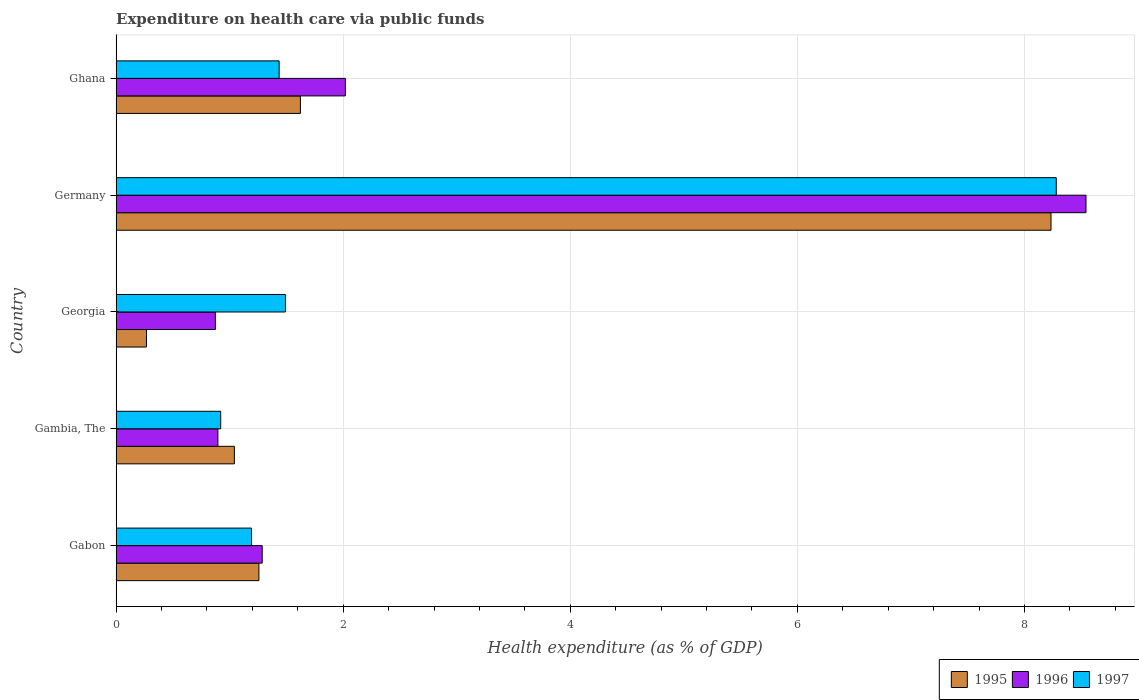How many different coloured bars are there?
Ensure brevity in your answer.  3. How many bars are there on the 3rd tick from the top?
Your answer should be very brief. 3. In how many cases, is the number of bars for a given country not equal to the number of legend labels?
Provide a succinct answer. 0. What is the expenditure made on health care in 1995 in Gambia, The?
Offer a very short reply. 1.04. Across all countries, what is the maximum expenditure made on health care in 1997?
Make the answer very short. 8.28. Across all countries, what is the minimum expenditure made on health care in 1997?
Offer a very short reply. 0.92. In which country was the expenditure made on health care in 1997 minimum?
Give a very brief answer. Gambia, The. What is the total expenditure made on health care in 1996 in the graph?
Provide a short and direct response. 13.62. What is the difference between the expenditure made on health care in 1997 in Germany and that in Ghana?
Provide a short and direct response. 6.84. What is the difference between the expenditure made on health care in 1996 in Ghana and the expenditure made on health care in 1997 in Gabon?
Your answer should be compact. 0.83. What is the average expenditure made on health care in 1995 per country?
Keep it short and to the point. 2.48. What is the difference between the expenditure made on health care in 1995 and expenditure made on health care in 1997 in Germany?
Give a very brief answer. -0.05. What is the ratio of the expenditure made on health care in 1995 in Gambia, The to that in Georgia?
Make the answer very short. 3.9. Is the expenditure made on health care in 1995 in Germany less than that in Ghana?
Provide a short and direct response. No. Is the difference between the expenditure made on health care in 1995 in Gabon and Germany greater than the difference between the expenditure made on health care in 1997 in Gabon and Germany?
Your response must be concise. Yes. What is the difference between the highest and the second highest expenditure made on health care in 1995?
Provide a short and direct response. 6.61. What is the difference between the highest and the lowest expenditure made on health care in 1996?
Keep it short and to the point. 7.67. Is the sum of the expenditure made on health care in 1996 in Gambia, The and Georgia greater than the maximum expenditure made on health care in 1995 across all countries?
Your answer should be very brief. No. What does the 2nd bar from the top in Georgia represents?
Offer a terse response. 1996. Is it the case that in every country, the sum of the expenditure made on health care in 1996 and expenditure made on health care in 1997 is greater than the expenditure made on health care in 1995?
Make the answer very short. Yes. How many bars are there?
Your answer should be compact. 15. Are all the bars in the graph horizontal?
Your response must be concise. Yes. Where does the legend appear in the graph?
Your answer should be very brief. Bottom right. How are the legend labels stacked?
Offer a terse response. Horizontal. What is the title of the graph?
Offer a terse response. Expenditure on health care via public funds. What is the label or title of the X-axis?
Ensure brevity in your answer.  Health expenditure (as % of GDP). What is the label or title of the Y-axis?
Keep it short and to the point. Country. What is the Health expenditure (as % of GDP) in 1995 in Gabon?
Provide a short and direct response. 1.26. What is the Health expenditure (as % of GDP) in 1996 in Gabon?
Offer a terse response. 1.29. What is the Health expenditure (as % of GDP) in 1997 in Gabon?
Your response must be concise. 1.19. What is the Health expenditure (as % of GDP) of 1995 in Gambia, The?
Make the answer very short. 1.04. What is the Health expenditure (as % of GDP) of 1996 in Gambia, The?
Your answer should be very brief. 0.9. What is the Health expenditure (as % of GDP) of 1997 in Gambia, The?
Your answer should be very brief. 0.92. What is the Health expenditure (as % of GDP) in 1995 in Georgia?
Your response must be concise. 0.27. What is the Health expenditure (as % of GDP) of 1996 in Georgia?
Provide a succinct answer. 0.87. What is the Health expenditure (as % of GDP) in 1997 in Georgia?
Offer a terse response. 1.49. What is the Health expenditure (as % of GDP) in 1995 in Germany?
Your response must be concise. 8.23. What is the Health expenditure (as % of GDP) of 1996 in Germany?
Make the answer very short. 8.54. What is the Health expenditure (as % of GDP) of 1997 in Germany?
Your answer should be compact. 8.28. What is the Health expenditure (as % of GDP) in 1995 in Ghana?
Offer a terse response. 1.62. What is the Health expenditure (as % of GDP) of 1996 in Ghana?
Provide a succinct answer. 2.02. What is the Health expenditure (as % of GDP) in 1997 in Ghana?
Provide a short and direct response. 1.44. Across all countries, what is the maximum Health expenditure (as % of GDP) in 1995?
Keep it short and to the point. 8.23. Across all countries, what is the maximum Health expenditure (as % of GDP) in 1996?
Offer a very short reply. 8.54. Across all countries, what is the maximum Health expenditure (as % of GDP) in 1997?
Provide a short and direct response. 8.28. Across all countries, what is the minimum Health expenditure (as % of GDP) in 1995?
Your answer should be compact. 0.27. Across all countries, what is the minimum Health expenditure (as % of GDP) of 1996?
Your response must be concise. 0.87. Across all countries, what is the minimum Health expenditure (as % of GDP) in 1997?
Offer a terse response. 0.92. What is the total Health expenditure (as % of GDP) of 1995 in the graph?
Ensure brevity in your answer.  12.42. What is the total Health expenditure (as % of GDP) in 1996 in the graph?
Provide a short and direct response. 13.62. What is the total Health expenditure (as % of GDP) in 1997 in the graph?
Offer a very short reply. 13.32. What is the difference between the Health expenditure (as % of GDP) in 1995 in Gabon and that in Gambia, The?
Offer a very short reply. 0.22. What is the difference between the Health expenditure (as % of GDP) of 1996 in Gabon and that in Gambia, The?
Make the answer very short. 0.39. What is the difference between the Health expenditure (as % of GDP) of 1997 in Gabon and that in Gambia, The?
Provide a short and direct response. 0.27. What is the difference between the Health expenditure (as % of GDP) of 1995 in Gabon and that in Georgia?
Offer a terse response. 0.99. What is the difference between the Health expenditure (as % of GDP) in 1996 in Gabon and that in Georgia?
Make the answer very short. 0.41. What is the difference between the Health expenditure (as % of GDP) of 1997 in Gabon and that in Georgia?
Your answer should be compact. -0.3. What is the difference between the Health expenditure (as % of GDP) in 1995 in Gabon and that in Germany?
Your answer should be very brief. -6.98. What is the difference between the Health expenditure (as % of GDP) in 1996 in Gabon and that in Germany?
Provide a succinct answer. -7.26. What is the difference between the Health expenditure (as % of GDP) of 1997 in Gabon and that in Germany?
Your answer should be compact. -7.09. What is the difference between the Health expenditure (as % of GDP) of 1995 in Gabon and that in Ghana?
Offer a terse response. -0.37. What is the difference between the Health expenditure (as % of GDP) in 1996 in Gabon and that in Ghana?
Give a very brief answer. -0.73. What is the difference between the Health expenditure (as % of GDP) in 1997 in Gabon and that in Ghana?
Your answer should be compact. -0.24. What is the difference between the Health expenditure (as % of GDP) of 1995 in Gambia, The and that in Georgia?
Your response must be concise. 0.77. What is the difference between the Health expenditure (as % of GDP) in 1996 in Gambia, The and that in Georgia?
Make the answer very short. 0.02. What is the difference between the Health expenditure (as % of GDP) of 1997 in Gambia, The and that in Georgia?
Offer a terse response. -0.57. What is the difference between the Health expenditure (as % of GDP) in 1995 in Gambia, The and that in Germany?
Provide a short and direct response. -7.19. What is the difference between the Health expenditure (as % of GDP) in 1996 in Gambia, The and that in Germany?
Your answer should be very brief. -7.65. What is the difference between the Health expenditure (as % of GDP) in 1997 in Gambia, The and that in Germany?
Your answer should be very brief. -7.36. What is the difference between the Health expenditure (as % of GDP) in 1995 in Gambia, The and that in Ghana?
Your answer should be compact. -0.58. What is the difference between the Health expenditure (as % of GDP) of 1996 in Gambia, The and that in Ghana?
Give a very brief answer. -1.12. What is the difference between the Health expenditure (as % of GDP) in 1997 in Gambia, The and that in Ghana?
Your answer should be compact. -0.51. What is the difference between the Health expenditure (as % of GDP) of 1995 in Georgia and that in Germany?
Offer a terse response. -7.97. What is the difference between the Health expenditure (as % of GDP) of 1996 in Georgia and that in Germany?
Ensure brevity in your answer.  -7.67. What is the difference between the Health expenditure (as % of GDP) of 1997 in Georgia and that in Germany?
Offer a terse response. -6.79. What is the difference between the Health expenditure (as % of GDP) of 1995 in Georgia and that in Ghana?
Offer a terse response. -1.36. What is the difference between the Health expenditure (as % of GDP) in 1996 in Georgia and that in Ghana?
Provide a short and direct response. -1.14. What is the difference between the Health expenditure (as % of GDP) of 1997 in Georgia and that in Ghana?
Offer a terse response. 0.06. What is the difference between the Health expenditure (as % of GDP) of 1995 in Germany and that in Ghana?
Ensure brevity in your answer.  6.61. What is the difference between the Health expenditure (as % of GDP) of 1996 in Germany and that in Ghana?
Make the answer very short. 6.52. What is the difference between the Health expenditure (as % of GDP) of 1997 in Germany and that in Ghana?
Your answer should be compact. 6.84. What is the difference between the Health expenditure (as % of GDP) in 1995 in Gabon and the Health expenditure (as % of GDP) in 1996 in Gambia, The?
Your answer should be compact. 0.36. What is the difference between the Health expenditure (as % of GDP) of 1995 in Gabon and the Health expenditure (as % of GDP) of 1997 in Gambia, The?
Give a very brief answer. 0.34. What is the difference between the Health expenditure (as % of GDP) in 1996 in Gabon and the Health expenditure (as % of GDP) in 1997 in Gambia, The?
Make the answer very short. 0.37. What is the difference between the Health expenditure (as % of GDP) in 1995 in Gabon and the Health expenditure (as % of GDP) in 1996 in Georgia?
Provide a short and direct response. 0.38. What is the difference between the Health expenditure (as % of GDP) of 1995 in Gabon and the Health expenditure (as % of GDP) of 1997 in Georgia?
Offer a very short reply. -0.23. What is the difference between the Health expenditure (as % of GDP) in 1996 in Gabon and the Health expenditure (as % of GDP) in 1997 in Georgia?
Keep it short and to the point. -0.2. What is the difference between the Health expenditure (as % of GDP) in 1995 in Gabon and the Health expenditure (as % of GDP) in 1996 in Germany?
Your answer should be compact. -7.28. What is the difference between the Health expenditure (as % of GDP) of 1995 in Gabon and the Health expenditure (as % of GDP) of 1997 in Germany?
Your response must be concise. -7.02. What is the difference between the Health expenditure (as % of GDP) of 1996 in Gabon and the Health expenditure (as % of GDP) of 1997 in Germany?
Offer a terse response. -6.99. What is the difference between the Health expenditure (as % of GDP) in 1995 in Gabon and the Health expenditure (as % of GDP) in 1996 in Ghana?
Your answer should be compact. -0.76. What is the difference between the Health expenditure (as % of GDP) in 1995 in Gabon and the Health expenditure (as % of GDP) in 1997 in Ghana?
Your response must be concise. -0.18. What is the difference between the Health expenditure (as % of GDP) in 1996 in Gabon and the Health expenditure (as % of GDP) in 1997 in Ghana?
Your response must be concise. -0.15. What is the difference between the Health expenditure (as % of GDP) of 1995 in Gambia, The and the Health expenditure (as % of GDP) of 1996 in Georgia?
Your answer should be compact. 0.17. What is the difference between the Health expenditure (as % of GDP) of 1995 in Gambia, The and the Health expenditure (as % of GDP) of 1997 in Georgia?
Keep it short and to the point. -0.45. What is the difference between the Health expenditure (as % of GDP) in 1996 in Gambia, The and the Health expenditure (as % of GDP) in 1997 in Georgia?
Your answer should be compact. -0.6. What is the difference between the Health expenditure (as % of GDP) in 1995 in Gambia, The and the Health expenditure (as % of GDP) in 1996 in Germany?
Your answer should be very brief. -7.5. What is the difference between the Health expenditure (as % of GDP) in 1995 in Gambia, The and the Health expenditure (as % of GDP) in 1997 in Germany?
Your response must be concise. -7.24. What is the difference between the Health expenditure (as % of GDP) of 1996 in Gambia, The and the Health expenditure (as % of GDP) of 1997 in Germany?
Your answer should be very brief. -7.38. What is the difference between the Health expenditure (as % of GDP) in 1995 in Gambia, The and the Health expenditure (as % of GDP) in 1996 in Ghana?
Your answer should be compact. -0.98. What is the difference between the Health expenditure (as % of GDP) in 1995 in Gambia, The and the Health expenditure (as % of GDP) in 1997 in Ghana?
Your answer should be very brief. -0.39. What is the difference between the Health expenditure (as % of GDP) of 1996 in Gambia, The and the Health expenditure (as % of GDP) of 1997 in Ghana?
Your response must be concise. -0.54. What is the difference between the Health expenditure (as % of GDP) of 1995 in Georgia and the Health expenditure (as % of GDP) of 1996 in Germany?
Provide a short and direct response. -8.27. What is the difference between the Health expenditure (as % of GDP) of 1995 in Georgia and the Health expenditure (as % of GDP) of 1997 in Germany?
Offer a terse response. -8.01. What is the difference between the Health expenditure (as % of GDP) in 1996 in Georgia and the Health expenditure (as % of GDP) in 1997 in Germany?
Ensure brevity in your answer.  -7.41. What is the difference between the Health expenditure (as % of GDP) in 1995 in Georgia and the Health expenditure (as % of GDP) in 1996 in Ghana?
Your response must be concise. -1.75. What is the difference between the Health expenditure (as % of GDP) in 1995 in Georgia and the Health expenditure (as % of GDP) in 1997 in Ghana?
Your answer should be compact. -1.17. What is the difference between the Health expenditure (as % of GDP) of 1996 in Georgia and the Health expenditure (as % of GDP) of 1997 in Ghana?
Your response must be concise. -0.56. What is the difference between the Health expenditure (as % of GDP) of 1995 in Germany and the Health expenditure (as % of GDP) of 1996 in Ghana?
Make the answer very short. 6.21. What is the difference between the Health expenditure (as % of GDP) of 1995 in Germany and the Health expenditure (as % of GDP) of 1997 in Ghana?
Keep it short and to the point. 6.8. What is the difference between the Health expenditure (as % of GDP) of 1996 in Germany and the Health expenditure (as % of GDP) of 1997 in Ghana?
Your response must be concise. 7.11. What is the average Health expenditure (as % of GDP) of 1995 per country?
Provide a short and direct response. 2.48. What is the average Health expenditure (as % of GDP) of 1996 per country?
Give a very brief answer. 2.72. What is the average Health expenditure (as % of GDP) of 1997 per country?
Keep it short and to the point. 2.66. What is the difference between the Health expenditure (as % of GDP) in 1995 and Health expenditure (as % of GDP) in 1996 in Gabon?
Your answer should be compact. -0.03. What is the difference between the Health expenditure (as % of GDP) in 1995 and Health expenditure (as % of GDP) in 1997 in Gabon?
Your response must be concise. 0.07. What is the difference between the Health expenditure (as % of GDP) in 1996 and Health expenditure (as % of GDP) in 1997 in Gabon?
Keep it short and to the point. 0.09. What is the difference between the Health expenditure (as % of GDP) in 1995 and Health expenditure (as % of GDP) in 1996 in Gambia, The?
Ensure brevity in your answer.  0.15. What is the difference between the Health expenditure (as % of GDP) in 1995 and Health expenditure (as % of GDP) in 1997 in Gambia, The?
Keep it short and to the point. 0.12. What is the difference between the Health expenditure (as % of GDP) of 1996 and Health expenditure (as % of GDP) of 1997 in Gambia, The?
Your answer should be compact. -0.02. What is the difference between the Health expenditure (as % of GDP) of 1995 and Health expenditure (as % of GDP) of 1996 in Georgia?
Give a very brief answer. -0.61. What is the difference between the Health expenditure (as % of GDP) of 1995 and Health expenditure (as % of GDP) of 1997 in Georgia?
Your answer should be very brief. -1.22. What is the difference between the Health expenditure (as % of GDP) in 1996 and Health expenditure (as % of GDP) in 1997 in Georgia?
Offer a very short reply. -0.62. What is the difference between the Health expenditure (as % of GDP) in 1995 and Health expenditure (as % of GDP) in 1996 in Germany?
Your answer should be very brief. -0.31. What is the difference between the Health expenditure (as % of GDP) of 1995 and Health expenditure (as % of GDP) of 1997 in Germany?
Provide a short and direct response. -0.05. What is the difference between the Health expenditure (as % of GDP) of 1996 and Health expenditure (as % of GDP) of 1997 in Germany?
Keep it short and to the point. 0.26. What is the difference between the Health expenditure (as % of GDP) of 1995 and Health expenditure (as % of GDP) of 1996 in Ghana?
Offer a terse response. -0.4. What is the difference between the Health expenditure (as % of GDP) of 1995 and Health expenditure (as % of GDP) of 1997 in Ghana?
Offer a terse response. 0.19. What is the difference between the Health expenditure (as % of GDP) of 1996 and Health expenditure (as % of GDP) of 1997 in Ghana?
Offer a very short reply. 0.58. What is the ratio of the Health expenditure (as % of GDP) of 1995 in Gabon to that in Gambia, The?
Your answer should be compact. 1.21. What is the ratio of the Health expenditure (as % of GDP) of 1996 in Gabon to that in Gambia, The?
Keep it short and to the point. 1.44. What is the ratio of the Health expenditure (as % of GDP) in 1997 in Gabon to that in Gambia, The?
Offer a very short reply. 1.29. What is the ratio of the Health expenditure (as % of GDP) of 1995 in Gabon to that in Georgia?
Provide a succinct answer. 4.7. What is the ratio of the Health expenditure (as % of GDP) in 1996 in Gabon to that in Georgia?
Ensure brevity in your answer.  1.47. What is the ratio of the Health expenditure (as % of GDP) of 1997 in Gabon to that in Georgia?
Provide a short and direct response. 0.8. What is the ratio of the Health expenditure (as % of GDP) of 1995 in Gabon to that in Germany?
Your answer should be very brief. 0.15. What is the ratio of the Health expenditure (as % of GDP) in 1996 in Gabon to that in Germany?
Provide a short and direct response. 0.15. What is the ratio of the Health expenditure (as % of GDP) of 1997 in Gabon to that in Germany?
Offer a very short reply. 0.14. What is the ratio of the Health expenditure (as % of GDP) in 1995 in Gabon to that in Ghana?
Your answer should be compact. 0.77. What is the ratio of the Health expenditure (as % of GDP) of 1996 in Gabon to that in Ghana?
Offer a very short reply. 0.64. What is the ratio of the Health expenditure (as % of GDP) of 1997 in Gabon to that in Ghana?
Your answer should be very brief. 0.83. What is the ratio of the Health expenditure (as % of GDP) of 1995 in Gambia, The to that in Georgia?
Keep it short and to the point. 3.9. What is the ratio of the Health expenditure (as % of GDP) in 1996 in Gambia, The to that in Georgia?
Your answer should be compact. 1.03. What is the ratio of the Health expenditure (as % of GDP) of 1997 in Gambia, The to that in Georgia?
Provide a succinct answer. 0.62. What is the ratio of the Health expenditure (as % of GDP) of 1995 in Gambia, The to that in Germany?
Offer a very short reply. 0.13. What is the ratio of the Health expenditure (as % of GDP) in 1996 in Gambia, The to that in Germany?
Ensure brevity in your answer.  0.1. What is the ratio of the Health expenditure (as % of GDP) in 1997 in Gambia, The to that in Germany?
Give a very brief answer. 0.11. What is the ratio of the Health expenditure (as % of GDP) of 1995 in Gambia, The to that in Ghana?
Your response must be concise. 0.64. What is the ratio of the Health expenditure (as % of GDP) of 1996 in Gambia, The to that in Ghana?
Provide a succinct answer. 0.44. What is the ratio of the Health expenditure (as % of GDP) in 1997 in Gambia, The to that in Ghana?
Provide a short and direct response. 0.64. What is the ratio of the Health expenditure (as % of GDP) of 1995 in Georgia to that in Germany?
Provide a short and direct response. 0.03. What is the ratio of the Health expenditure (as % of GDP) of 1996 in Georgia to that in Germany?
Give a very brief answer. 0.1. What is the ratio of the Health expenditure (as % of GDP) in 1997 in Georgia to that in Germany?
Offer a terse response. 0.18. What is the ratio of the Health expenditure (as % of GDP) in 1995 in Georgia to that in Ghana?
Provide a succinct answer. 0.16. What is the ratio of the Health expenditure (as % of GDP) in 1996 in Georgia to that in Ghana?
Give a very brief answer. 0.43. What is the ratio of the Health expenditure (as % of GDP) in 1997 in Georgia to that in Ghana?
Provide a succinct answer. 1.04. What is the ratio of the Health expenditure (as % of GDP) in 1995 in Germany to that in Ghana?
Keep it short and to the point. 5.07. What is the ratio of the Health expenditure (as % of GDP) in 1996 in Germany to that in Ghana?
Offer a very short reply. 4.23. What is the ratio of the Health expenditure (as % of GDP) in 1997 in Germany to that in Ghana?
Ensure brevity in your answer.  5.77. What is the difference between the highest and the second highest Health expenditure (as % of GDP) of 1995?
Your response must be concise. 6.61. What is the difference between the highest and the second highest Health expenditure (as % of GDP) in 1996?
Offer a very short reply. 6.52. What is the difference between the highest and the second highest Health expenditure (as % of GDP) in 1997?
Make the answer very short. 6.79. What is the difference between the highest and the lowest Health expenditure (as % of GDP) in 1995?
Your answer should be very brief. 7.97. What is the difference between the highest and the lowest Health expenditure (as % of GDP) in 1996?
Give a very brief answer. 7.67. What is the difference between the highest and the lowest Health expenditure (as % of GDP) in 1997?
Give a very brief answer. 7.36. 